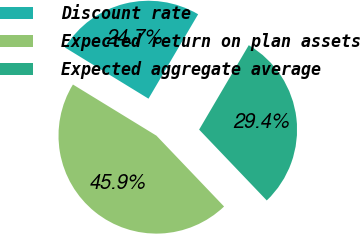Convert chart. <chart><loc_0><loc_0><loc_500><loc_500><pie_chart><fcel>Discount rate<fcel>Expected return on plan assets<fcel>Expected aggregate average<nl><fcel>24.71%<fcel>45.88%<fcel>29.41%<nl></chart> 